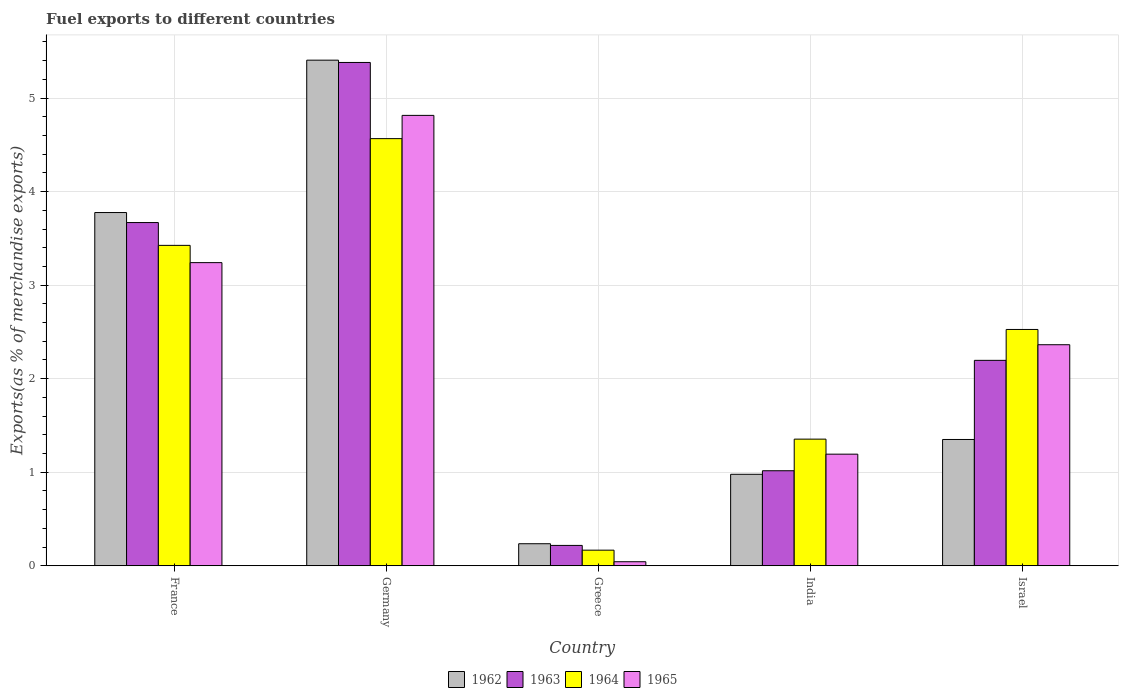Are the number of bars on each tick of the X-axis equal?
Offer a very short reply. Yes. How many bars are there on the 2nd tick from the left?
Ensure brevity in your answer.  4. How many bars are there on the 3rd tick from the right?
Offer a very short reply. 4. In how many cases, is the number of bars for a given country not equal to the number of legend labels?
Give a very brief answer. 0. What is the percentage of exports to different countries in 1962 in France?
Offer a terse response. 3.78. Across all countries, what is the maximum percentage of exports to different countries in 1962?
Ensure brevity in your answer.  5.4. Across all countries, what is the minimum percentage of exports to different countries in 1962?
Your answer should be compact. 0.24. What is the total percentage of exports to different countries in 1964 in the graph?
Provide a succinct answer. 12.04. What is the difference between the percentage of exports to different countries in 1963 in Germany and that in Greece?
Ensure brevity in your answer.  5.16. What is the difference between the percentage of exports to different countries in 1964 in Israel and the percentage of exports to different countries in 1963 in India?
Give a very brief answer. 1.51. What is the average percentage of exports to different countries in 1962 per country?
Your answer should be compact. 2.35. What is the difference between the percentage of exports to different countries of/in 1964 and percentage of exports to different countries of/in 1963 in France?
Give a very brief answer. -0.24. In how many countries, is the percentage of exports to different countries in 1963 greater than 0.4 %?
Your answer should be compact. 4. What is the ratio of the percentage of exports to different countries in 1963 in France to that in India?
Offer a very short reply. 3.61. Is the difference between the percentage of exports to different countries in 1964 in Germany and Israel greater than the difference between the percentage of exports to different countries in 1963 in Germany and Israel?
Your answer should be compact. No. What is the difference between the highest and the second highest percentage of exports to different countries in 1964?
Provide a short and direct response. -0.9. What is the difference between the highest and the lowest percentage of exports to different countries in 1965?
Make the answer very short. 4.77. In how many countries, is the percentage of exports to different countries in 1964 greater than the average percentage of exports to different countries in 1964 taken over all countries?
Provide a short and direct response. 3. What does the 4th bar from the left in India represents?
Provide a short and direct response. 1965. What does the 3rd bar from the right in Germany represents?
Ensure brevity in your answer.  1963. How many bars are there?
Provide a short and direct response. 20. What is the difference between two consecutive major ticks on the Y-axis?
Offer a very short reply. 1. Are the values on the major ticks of Y-axis written in scientific E-notation?
Ensure brevity in your answer.  No. How many legend labels are there?
Your response must be concise. 4. How are the legend labels stacked?
Make the answer very short. Horizontal. What is the title of the graph?
Make the answer very short. Fuel exports to different countries. What is the label or title of the X-axis?
Offer a terse response. Country. What is the label or title of the Y-axis?
Keep it short and to the point. Exports(as % of merchandise exports). What is the Exports(as % of merchandise exports) in 1962 in France?
Provide a succinct answer. 3.78. What is the Exports(as % of merchandise exports) of 1963 in France?
Offer a very short reply. 3.67. What is the Exports(as % of merchandise exports) in 1964 in France?
Your response must be concise. 3.43. What is the Exports(as % of merchandise exports) in 1965 in France?
Your answer should be compact. 3.24. What is the Exports(as % of merchandise exports) of 1962 in Germany?
Offer a very short reply. 5.4. What is the Exports(as % of merchandise exports) in 1963 in Germany?
Your response must be concise. 5.38. What is the Exports(as % of merchandise exports) of 1964 in Germany?
Provide a succinct answer. 4.57. What is the Exports(as % of merchandise exports) in 1965 in Germany?
Make the answer very short. 4.81. What is the Exports(as % of merchandise exports) of 1962 in Greece?
Your answer should be compact. 0.24. What is the Exports(as % of merchandise exports) in 1963 in Greece?
Offer a terse response. 0.22. What is the Exports(as % of merchandise exports) in 1964 in Greece?
Provide a succinct answer. 0.17. What is the Exports(as % of merchandise exports) in 1965 in Greece?
Provide a short and direct response. 0.04. What is the Exports(as % of merchandise exports) in 1962 in India?
Offer a terse response. 0.98. What is the Exports(as % of merchandise exports) of 1963 in India?
Give a very brief answer. 1.02. What is the Exports(as % of merchandise exports) in 1964 in India?
Give a very brief answer. 1.35. What is the Exports(as % of merchandise exports) in 1965 in India?
Keep it short and to the point. 1.19. What is the Exports(as % of merchandise exports) in 1962 in Israel?
Your response must be concise. 1.35. What is the Exports(as % of merchandise exports) in 1963 in Israel?
Keep it short and to the point. 2.2. What is the Exports(as % of merchandise exports) of 1964 in Israel?
Give a very brief answer. 2.53. What is the Exports(as % of merchandise exports) of 1965 in Israel?
Provide a short and direct response. 2.36. Across all countries, what is the maximum Exports(as % of merchandise exports) of 1962?
Ensure brevity in your answer.  5.4. Across all countries, what is the maximum Exports(as % of merchandise exports) in 1963?
Provide a short and direct response. 5.38. Across all countries, what is the maximum Exports(as % of merchandise exports) of 1964?
Give a very brief answer. 4.57. Across all countries, what is the maximum Exports(as % of merchandise exports) of 1965?
Ensure brevity in your answer.  4.81. Across all countries, what is the minimum Exports(as % of merchandise exports) in 1962?
Your answer should be compact. 0.24. Across all countries, what is the minimum Exports(as % of merchandise exports) of 1963?
Your response must be concise. 0.22. Across all countries, what is the minimum Exports(as % of merchandise exports) of 1964?
Your response must be concise. 0.17. Across all countries, what is the minimum Exports(as % of merchandise exports) of 1965?
Make the answer very short. 0.04. What is the total Exports(as % of merchandise exports) of 1962 in the graph?
Offer a terse response. 11.75. What is the total Exports(as % of merchandise exports) of 1963 in the graph?
Provide a succinct answer. 12.48. What is the total Exports(as % of merchandise exports) in 1964 in the graph?
Give a very brief answer. 12.04. What is the total Exports(as % of merchandise exports) of 1965 in the graph?
Provide a succinct answer. 11.66. What is the difference between the Exports(as % of merchandise exports) of 1962 in France and that in Germany?
Offer a terse response. -1.63. What is the difference between the Exports(as % of merchandise exports) in 1963 in France and that in Germany?
Offer a terse response. -1.71. What is the difference between the Exports(as % of merchandise exports) of 1964 in France and that in Germany?
Provide a short and direct response. -1.14. What is the difference between the Exports(as % of merchandise exports) of 1965 in France and that in Germany?
Your response must be concise. -1.57. What is the difference between the Exports(as % of merchandise exports) in 1962 in France and that in Greece?
Your answer should be compact. 3.54. What is the difference between the Exports(as % of merchandise exports) in 1963 in France and that in Greece?
Offer a terse response. 3.45. What is the difference between the Exports(as % of merchandise exports) in 1964 in France and that in Greece?
Provide a short and direct response. 3.26. What is the difference between the Exports(as % of merchandise exports) in 1965 in France and that in Greece?
Offer a very short reply. 3.2. What is the difference between the Exports(as % of merchandise exports) in 1962 in France and that in India?
Offer a very short reply. 2.8. What is the difference between the Exports(as % of merchandise exports) in 1963 in France and that in India?
Give a very brief answer. 2.65. What is the difference between the Exports(as % of merchandise exports) in 1964 in France and that in India?
Ensure brevity in your answer.  2.07. What is the difference between the Exports(as % of merchandise exports) in 1965 in France and that in India?
Make the answer very short. 2.05. What is the difference between the Exports(as % of merchandise exports) in 1962 in France and that in Israel?
Make the answer very short. 2.43. What is the difference between the Exports(as % of merchandise exports) of 1963 in France and that in Israel?
Your answer should be very brief. 1.47. What is the difference between the Exports(as % of merchandise exports) in 1964 in France and that in Israel?
Your answer should be compact. 0.9. What is the difference between the Exports(as % of merchandise exports) of 1965 in France and that in Israel?
Make the answer very short. 0.88. What is the difference between the Exports(as % of merchandise exports) in 1962 in Germany and that in Greece?
Your response must be concise. 5.17. What is the difference between the Exports(as % of merchandise exports) of 1963 in Germany and that in Greece?
Offer a very short reply. 5.16. What is the difference between the Exports(as % of merchandise exports) in 1964 in Germany and that in Greece?
Make the answer very short. 4.4. What is the difference between the Exports(as % of merchandise exports) in 1965 in Germany and that in Greece?
Offer a terse response. 4.77. What is the difference between the Exports(as % of merchandise exports) in 1962 in Germany and that in India?
Offer a very short reply. 4.43. What is the difference between the Exports(as % of merchandise exports) of 1963 in Germany and that in India?
Provide a short and direct response. 4.36. What is the difference between the Exports(as % of merchandise exports) in 1964 in Germany and that in India?
Give a very brief answer. 3.21. What is the difference between the Exports(as % of merchandise exports) in 1965 in Germany and that in India?
Keep it short and to the point. 3.62. What is the difference between the Exports(as % of merchandise exports) of 1962 in Germany and that in Israel?
Give a very brief answer. 4.05. What is the difference between the Exports(as % of merchandise exports) in 1963 in Germany and that in Israel?
Provide a short and direct response. 3.18. What is the difference between the Exports(as % of merchandise exports) of 1964 in Germany and that in Israel?
Offer a very short reply. 2.04. What is the difference between the Exports(as % of merchandise exports) in 1965 in Germany and that in Israel?
Make the answer very short. 2.45. What is the difference between the Exports(as % of merchandise exports) in 1962 in Greece and that in India?
Your answer should be compact. -0.74. What is the difference between the Exports(as % of merchandise exports) of 1963 in Greece and that in India?
Ensure brevity in your answer.  -0.8. What is the difference between the Exports(as % of merchandise exports) in 1964 in Greece and that in India?
Make the answer very short. -1.19. What is the difference between the Exports(as % of merchandise exports) of 1965 in Greece and that in India?
Provide a succinct answer. -1.15. What is the difference between the Exports(as % of merchandise exports) in 1962 in Greece and that in Israel?
Give a very brief answer. -1.11. What is the difference between the Exports(as % of merchandise exports) of 1963 in Greece and that in Israel?
Your answer should be compact. -1.98. What is the difference between the Exports(as % of merchandise exports) in 1964 in Greece and that in Israel?
Provide a succinct answer. -2.36. What is the difference between the Exports(as % of merchandise exports) of 1965 in Greece and that in Israel?
Keep it short and to the point. -2.32. What is the difference between the Exports(as % of merchandise exports) of 1962 in India and that in Israel?
Your answer should be very brief. -0.37. What is the difference between the Exports(as % of merchandise exports) of 1963 in India and that in Israel?
Offer a terse response. -1.18. What is the difference between the Exports(as % of merchandise exports) of 1964 in India and that in Israel?
Provide a succinct answer. -1.17. What is the difference between the Exports(as % of merchandise exports) in 1965 in India and that in Israel?
Your answer should be compact. -1.17. What is the difference between the Exports(as % of merchandise exports) of 1962 in France and the Exports(as % of merchandise exports) of 1963 in Germany?
Give a very brief answer. -1.6. What is the difference between the Exports(as % of merchandise exports) of 1962 in France and the Exports(as % of merchandise exports) of 1964 in Germany?
Give a very brief answer. -0.79. What is the difference between the Exports(as % of merchandise exports) in 1962 in France and the Exports(as % of merchandise exports) in 1965 in Germany?
Give a very brief answer. -1.04. What is the difference between the Exports(as % of merchandise exports) of 1963 in France and the Exports(as % of merchandise exports) of 1964 in Germany?
Your answer should be compact. -0.9. What is the difference between the Exports(as % of merchandise exports) of 1963 in France and the Exports(as % of merchandise exports) of 1965 in Germany?
Keep it short and to the point. -1.15. What is the difference between the Exports(as % of merchandise exports) of 1964 in France and the Exports(as % of merchandise exports) of 1965 in Germany?
Provide a succinct answer. -1.39. What is the difference between the Exports(as % of merchandise exports) of 1962 in France and the Exports(as % of merchandise exports) of 1963 in Greece?
Your answer should be compact. 3.56. What is the difference between the Exports(as % of merchandise exports) of 1962 in France and the Exports(as % of merchandise exports) of 1964 in Greece?
Your answer should be compact. 3.61. What is the difference between the Exports(as % of merchandise exports) in 1962 in France and the Exports(as % of merchandise exports) in 1965 in Greece?
Your answer should be compact. 3.73. What is the difference between the Exports(as % of merchandise exports) of 1963 in France and the Exports(as % of merchandise exports) of 1964 in Greece?
Make the answer very short. 3.5. What is the difference between the Exports(as % of merchandise exports) in 1963 in France and the Exports(as % of merchandise exports) in 1965 in Greece?
Provide a short and direct response. 3.63. What is the difference between the Exports(as % of merchandise exports) of 1964 in France and the Exports(as % of merchandise exports) of 1965 in Greece?
Your answer should be very brief. 3.38. What is the difference between the Exports(as % of merchandise exports) in 1962 in France and the Exports(as % of merchandise exports) in 1963 in India?
Provide a short and direct response. 2.76. What is the difference between the Exports(as % of merchandise exports) of 1962 in France and the Exports(as % of merchandise exports) of 1964 in India?
Provide a succinct answer. 2.42. What is the difference between the Exports(as % of merchandise exports) in 1962 in France and the Exports(as % of merchandise exports) in 1965 in India?
Your response must be concise. 2.58. What is the difference between the Exports(as % of merchandise exports) of 1963 in France and the Exports(as % of merchandise exports) of 1964 in India?
Your answer should be compact. 2.32. What is the difference between the Exports(as % of merchandise exports) in 1963 in France and the Exports(as % of merchandise exports) in 1965 in India?
Keep it short and to the point. 2.48. What is the difference between the Exports(as % of merchandise exports) of 1964 in France and the Exports(as % of merchandise exports) of 1965 in India?
Offer a terse response. 2.23. What is the difference between the Exports(as % of merchandise exports) of 1962 in France and the Exports(as % of merchandise exports) of 1963 in Israel?
Your answer should be compact. 1.58. What is the difference between the Exports(as % of merchandise exports) in 1962 in France and the Exports(as % of merchandise exports) in 1964 in Israel?
Provide a succinct answer. 1.25. What is the difference between the Exports(as % of merchandise exports) of 1962 in France and the Exports(as % of merchandise exports) of 1965 in Israel?
Ensure brevity in your answer.  1.41. What is the difference between the Exports(as % of merchandise exports) of 1963 in France and the Exports(as % of merchandise exports) of 1964 in Israel?
Ensure brevity in your answer.  1.14. What is the difference between the Exports(as % of merchandise exports) of 1963 in France and the Exports(as % of merchandise exports) of 1965 in Israel?
Offer a very short reply. 1.31. What is the difference between the Exports(as % of merchandise exports) in 1964 in France and the Exports(as % of merchandise exports) in 1965 in Israel?
Ensure brevity in your answer.  1.06. What is the difference between the Exports(as % of merchandise exports) in 1962 in Germany and the Exports(as % of merchandise exports) in 1963 in Greece?
Your response must be concise. 5.19. What is the difference between the Exports(as % of merchandise exports) of 1962 in Germany and the Exports(as % of merchandise exports) of 1964 in Greece?
Your answer should be very brief. 5.24. What is the difference between the Exports(as % of merchandise exports) of 1962 in Germany and the Exports(as % of merchandise exports) of 1965 in Greece?
Offer a terse response. 5.36. What is the difference between the Exports(as % of merchandise exports) of 1963 in Germany and the Exports(as % of merchandise exports) of 1964 in Greece?
Give a very brief answer. 5.21. What is the difference between the Exports(as % of merchandise exports) in 1963 in Germany and the Exports(as % of merchandise exports) in 1965 in Greece?
Your answer should be compact. 5.34. What is the difference between the Exports(as % of merchandise exports) in 1964 in Germany and the Exports(as % of merchandise exports) in 1965 in Greece?
Keep it short and to the point. 4.52. What is the difference between the Exports(as % of merchandise exports) of 1962 in Germany and the Exports(as % of merchandise exports) of 1963 in India?
Offer a terse response. 4.39. What is the difference between the Exports(as % of merchandise exports) in 1962 in Germany and the Exports(as % of merchandise exports) in 1964 in India?
Your answer should be very brief. 4.05. What is the difference between the Exports(as % of merchandise exports) of 1962 in Germany and the Exports(as % of merchandise exports) of 1965 in India?
Offer a very short reply. 4.21. What is the difference between the Exports(as % of merchandise exports) in 1963 in Germany and the Exports(as % of merchandise exports) in 1964 in India?
Keep it short and to the point. 4.03. What is the difference between the Exports(as % of merchandise exports) in 1963 in Germany and the Exports(as % of merchandise exports) in 1965 in India?
Ensure brevity in your answer.  4.19. What is the difference between the Exports(as % of merchandise exports) in 1964 in Germany and the Exports(as % of merchandise exports) in 1965 in India?
Ensure brevity in your answer.  3.37. What is the difference between the Exports(as % of merchandise exports) in 1962 in Germany and the Exports(as % of merchandise exports) in 1963 in Israel?
Your answer should be very brief. 3.21. What is the difference between the Exports(as % of merchandise exports) in 1962 in Germany and the Exports(as % of merchandise exports) in 1964 in Israel?
Offer a very short reply. 2.88. What is the difference between the Exports(as % of merchandise exports) of 1962 in Germany and the Exports(as % of merchandise exports) of 1965 in Israel?
Your answer should be compact. 3.04. What is the difference between the Exports(as % of merchandise exports) of 1963 in Germany and the Exports(as % of merchandise exports) of 1964 in Israel?
Provide a succinct answer. 2.85. What is the difference between the Exports(as % of merchandise exports) in 1963 in Germany and the Exports(as % of merchandise exports) in 1965 in Israel?
Offer a terse response. 3.02. What is the difference between the Exports(as % of merchandise exports) in 1964 in Germany and the Exports(as % of merchandise exports) in 1965 in Israel?
Your answer should be compact. 2.2. What is the difference between the Exports(as % of merchandise exports) of 1962 in Greece and the Exports(as % of merchandise exports) of 1963 in India?
Ensure brevity in your answer.  -0.78. What is the difference between the Exports(as % of merchandise exports) in 1962 in Greece and the Exports(as % of merchandise exports) in 1964 in India?
Offer a terse response. -1.12. What is the difference between the Exports(as % of merchandise exports) of 1962 in Greece and the Exports(as % of merchandise exports) of 1965 in India?
Provide a short and direct response. -0.96. What is the difference between the Exports(as % of merchandise exports) in 1963 in Greece and the Exports(as % of merchandise exports) in 1964 in India?
Provide a short and direct response. -1.14. What is the difference between the Exports(as % of merchandise exports) of 1963 in Greece and the Exports(as % of merchandise exports) of 1965 in India?
Provide a succinct answer. -0.98. What is the difference between the Exports(as % of merchandise exports) in 1964 in Greece and the Exports(as % of merchandise exports) in 1965 in India?
Make the answer very short. -1.03. What is the difference between the Exports(as % of merchandise exports) in 1962 in Greece and the Exports(as % of merchandise exports) in 1963 in Israel?
Provide a short and direct response. -1.96. What is the difference between the Exports(as % of merchandise exports) of 1962 in Greece and the Exports(as % of merchandise exports) of 1964 in Israel?
Keep it short and to the point. -2.29. What is the difference between the Exports(as % of merchandise exports) of 1962 in Greece and the Exports(as % of merchandise exports) of 1965 in Israel?
Provide a succinct answer. -2.13. What is the difference between the Exports(as % of merchandise exports) of 1963 in Greece and the Exports(as % of merchandise exports) of 1964 in Israel?
Your response must be concise. -2.31. What is the difference between the Exports(as % of merchandise exports) in 1963 in Greece and the Exports(as % of merchandise exports) in 1965 in Israel?
Provide a succinct answer. -2.15. What is the difference between the Exports(as % of merchandise exports) of 1964 in Greece and the Exports(as % of merchandise exports) of 1965 in Israel?
Provide a succinct answer. -2.2. What is the difference between the Exports(as % of merchandise exports) in 1962 in India and the Exports(as % of merchandise exports) in 1963 in Israel?
Provide a short and direct response. -1.22. What is the difference between the Exports(as % of merchandise exports) in 1962 in India and the Exports(as % of merchandise exports) in 1964 in Israel?
Make the answer very short. -1.55. What is the difference between the Exports(as % of merchandise exports) in 1962 in India and the Exports(as % of merchandise exports) in 1965 in Israel?
Provide a succinct answer. -1.38. What is the difference between the Exports(as % of merchandise exports) in 1963 in India and the Exports(as % of merchandise exports) in 1964 in Israel?
Offer a terse response. -1.51. What is the difference between the Exports(as % of merchandise exports) in 1963 in India and the Exports(as % of merchandise exports) in 1965 in Israel?
Keep it short and to the point. -1.35. What is the difference between the Exports(as % of merchandise exports) in 1964 in India and the Exports(as % of merchandise exports) in 1965 in Israel?
Your answer should be compact. -1.01. What is the average Exports(as % of merchandise exports) in 1962 per country?
Offer a very short reply. 2.35. What is the average Exports(as % of merchandise exports) of 1963 per country?
Your answer should be compact. 2.5. What is the average Exports(as % of merchandise exports) of 1964 per country?
Offer a very short reply. 2.41. What is the average Exports(as % of merchandise exports) in 1965 per country?
Provide a short and direct response. 2.33. What is the difference between the Exports(as % of merchandise exports) of 1962 and Exports(as % of merchandise exports) of 1963 in France?
Your answer should be very brief. 0.11. What is the difference between the Exports(as % of merchandise exports) in 1962 and Exports(as % of merchandise exports) in 1964 in France?
Your response must be concise. 0.35. What is the difference between the Exports(as % of merchandise exports) in 1962 and Exports(as % of merchandise exports) in 1965 in France?
Give a very brief answer. 0.54. What is the difference between the Exports(as % of merchandise exports) of 1963 and Exports(as % of merchandise exports) of 1964 in France?
Offer a very short reply. 0.24. What is the difference between the Exports(as % of merchandise exports) of 1963 and Exports(as % of merchandise exports) of 1965 in France?
Provide a short and direct response. 0.43. What is the difference between the Exports(as % of merchandise exports) of 1964 and Exports(as % of merchandise exports) of 1965 in France?
Your response must be concise. 0.18. What is the difference between the Exports(as % of merchandise exports) of 1962 and Exports(as % of merchandise exports) of 1963 in Germany?
Ensure brevity in your answer.  0.02. What is the difference between the Exports(as % of merchandise exports) of 1962 and Exports(as % of merchandise exports) of 1964 in Germany?
Your answer should be very brief. 0.84. What is the difference between the Exports(as % of merchandise exports) in 1962 and Exports(as % of merchandise exports) in 1965 in Germany?
Provide a succinct answer. 0.59. What is the difference between the Exports(as % of merchandise exports) in 1963 and Exports(as % of merchandise exports) in 1964 in Germany?
Keep it short and to the point. 0.81. What is the difference between the Exports(as % of merchandise exports) in 1963 and Exports(as % of merchandise exports) in 1965 in Germany?
Provide a short and direct response. 0.57. What is the difference between the Exports(as % of merchandise exports) in 1964 and Exports(as % of merchandise exports) in 1965 in Germany?
Offer a terse response. -0.25. What is the difference between the Exports(as % of merchandise exports) of 1962 and Exports(as % of merchandise exports) of 1963 in Greece?
Give a very brief answer. 0.02. What is the difference between the Exports(as % of merchandise exports) of 1962 and Exports(as % of merchandise exports) of 1964 in Greece?
Make the answer very short. 0.07. What is the difference between the Exports(as % of merchandise exports) in 1962 and Exports(as % of merchandise exports) in 1965 in Greece?
Your answer should be very brief. 0.19. What is the difference between the Exports(as % of merchandise exports) in 1963 and Exports(as % of merchandise exports) in 1964 in Greece?
Your answer should be compact. 0.05. What is the difference between the Exports(as % of merchandise exports) of 1963 and Exports(as % of merchandise exports) of 1965 in Greece?
Offer a terse response. 0.17. What is the difference between the Exports(as % of merchandise exports) in 1964 and Exports(as % of merchandise exports) in 1965 in Greece?
Offer a terse response. 0.12. What is the difference between the Exports(as % of merchandise exports) in 1962 and Exports(as % of merchandise exports) in 1963 in India?
Offer a very short reply. -0.04. What is the difference between the Exports(as % of merchandise exports) of 1962 and Exports(as % of merchandise exports) of 1964 in India?
Keep it short and to the point. -0.38. What is the difference between the Exports(as % of merchandise exports) of 1962 and Exports(as % of merchandise exports) of 1965 in India?
Ensure brevity in your answer.  -0.22. What is the difference between the Exports(as % of merchandise exports) of 1963 and Exports(as % of merchandise exports) of 1964 in India?
Provide a short and direct response. -0.34. What is the difference between the Exports(as % of merchandise exports) of 1963 and Exports(as % of merchandise exports) of 1965 in India?
Offer a very short reply. -0.18. What is the difference between the Exports(as % of merchandise exports) in 1964 and Exports(as % of merchandise exports) in 1965 in India?
Offer a very short reply. 0.16. What is the difference between the Exports(as % of merchandise exports) in 1962 and Exports(as % of merchandise exports) in 1963 in Israel?
Your answer should be very brief. -0.85. What is the difference between the Exports(as % of merchandise exports) of 1962 and Exports(as % of merchandise exports) of 1964 in Israel?
Your answer should be very brief. -1.18. What is the difference between the Exports(as % of merchandise exports) of 1962 and Exports(as % of merchandise exports) of 1965 in Israel?
Your response must be concise. -1.01. What is the difference between the Exports(as % of merchandise exports) in 1963 and Exports(as % of merchandise exports) in 1964 in Israel?
Make the answer very short. -0.33. What is the difference between the Exports(as % of merchandise exports) in 1963 and Exports(as % of merchandise exports) in 1965 in Israel?
Your answer should be very brief. -0.17. What is the difference between the Exports(as % of merchandise exports) of 1964 and Exports(as % of merchandise exports) of 1965 in Israel?
Provide a short and direct response. 0.16. What is the ratio of the Exports(as % of merchandise exports) of 1962 in France to that in Germany?
Provide a short and direct response. 0.7. What is the ratio of the Exports(as % of merchandise exports) in 1963 in France to that in Germany?
Provide a short and direct response. 0.68. What is the ratio of the Exports(as % of merchandise exports) of 1964 in France to that in Germany?
Make the answer very short. 0.75. What is the ratio of the Exports(as % of merchandise exports) of 1965 in France to that in Germany?
Provide a short and direct response. 0.67. What is the ratio of the Exports(as % of merchandise exports) of 1962 in France to that in Greece?
Make the answer very short. 16.01. What is the ratio of the Exports(as % of merchandise exports) in 1963 in France to that in Greece?
Keep it short and to the point. 16.85. What is the ratio of the Exports(as % of merchandise exports) in 1964 in France to that in Greece?
Your answer should be compact. 20.5. What is the ratio of the Exports(as % of merchandise exports) of 1965 in France to that in Greece?
Ensure brevity in your answer.  74.69. What is the ratio of the Exports(as % of merchandise exports) of 1962 in France to that in India?
Keep it short and to the point. 3.86. What is the ratio of the Exports(as % of merchandise exports) in 1963 in France to that in India?
Provide a short and direct response. 3.61. What is the ratio of the Exports(as % of merchandise exports) in 1964 in France to that in India?
Give a very brief answer. 2.53. What is the ratio of the Exports(as % of merchandise exports) of 1965 in France to that in India?
Make the answer very short. 2.72. What is the ratio of the Exports(as % of merchandise exports) of 1962 in France to that in Israel?
Your answer should be compact. 2.8. What is the ratio of the Exports(as % of merchandise exports) of 1963 in France to that in Israel?
Your response must be concise. 1.67. What is the ratio of the Exports(as % of merchandise exports) of 1964 in France to that in Israel?
Offer a terse response. 1.36. What is the ratio of the Exports(as % of merchandise exports) in 1965 in France to that in Israel?
Offer a terse response. 1.37. What is the ratio of the Exports(as % of merchandise exports) of 1962 in Germany to that in Greece?
Your answer should be compact. 22.91. What is the ratio of the Exports(as % of merchandise exports) of 1963 in Germany to that in Greece?
Your answer should be compact. 24.71. What is the ratio of the Exports(as % of merchandise exports) of 1964 in Germany to that in Greece?
Give a very brief answer. 27.34. What is the ratio of the Exports(as % of merchandise exports) in 1965 in Germany to that in Greece?
Ensure brevity in your answer.  110.96. What is the ratio of the Exports(as % of merchandise exports) in 1962 in Germany to that in India?
Provide a succinct answer. 5.53. What is the ratio of the Exports(as % of merchandise exports) in 1963 in Germany to that in India?
Offer a very short reply. 5.3. What is the ratio of the Exports(as % of merchandise exports) of 1964 in Germany to that in India?
Keep it short and to the point. 3.37. What is the ratio of the Exports(as % of merchandise exports) of 1965 in Germany to that in India?
Your response must be concise. 4.03. What is the ratio of the Exports(as % of merchandise exports) of 1962 in Germany to that in Israel?
Provide a succinct answer. 4. What is the ratio of the Exports(as % of merchandise exports) of 1963 in Germany to that in Israel?
Your response must be concise. 2.45. What is the ratio of the Exports(as % of merchandise exports) of 1964 in Germany to that in Israel?
Keep it short and to the point. 1.81. What is the ratio of the Exports(as % of merchandise exports) in 1965 in Germany to that in Israel?
Ensure brevity in your answer.  2.04. What is the ratio of the Exports(as % of merchandise exports) of 1962 in Greece to that in India?
Keep it short and to the point. 0.24. What is the ratio of the Exports(as % of merchandise exports) of 1963 in Greece to that in India?
Your response must be concise. 0.21. What is the ratio of the Exports(as % of merchandise exports) in 1964 in Greece to that in India?
Keep it short and to the point. 0.12. What is the ratio of the Exports(as % of merchandise exports) of 1965 in Greece to that in India?
Your answer should be very brief. 0.04. What is the ratio of the Exports(as % of merchandise exports) in 1962 in Greece to that in Israel?
Your response must be concise. 0.17. What is the ratio of the Exports(as % of merchandise exports) in 1963 in Greece to that in Israel?
Offer a terse response. 0.1. What is the ratio of the Exports(as % of merchandise exports) of 1964 in Greece to that in Israel?
Your answer should be compact. 0.07. What is the ratio of the Exports(as % of merchandise exports) of 1965 in Greece to that in Israel?
Provide a short and direct response. 0.02. What is the ratio of the Exports(as % of merchandise exports) in 1962 in India to that in Israel?
Provide a succinct answer. 0.72. What is the ratio of the Exports(as % of merchandise exports) in 1963 in India to that in Israel?
Your response must be concise. 0.46. What is the ratio of the Exports(as % of merchandise exports) in 1964 in India to that in Israel?
Provide a short and direct response. 0.54. What is the ratio of the Exports(as % of merchandise exports) in 1965 in India to that in Israel?
Offer a very short reply. 0.51. What is the difference between the highest and the second highest Exports(as % of merchandise exports) of 1962?
Offer a terse response. 1.63. What is the difference between the highest and the second highest Exports(as % of merchandise exports) of 1963?
Offer a very short reply. 1.71. What is the difference between the highest and the second highest Exports(as % of merchandise exports) of 1964?
Offer a terse response. 1.14. What is the difference between the highest and the second highest Exports(as % of merchandise exports) of 1965?
Your answer should be compact. 1.57. What is the difference between the highest and the lowest Exports(as % of merchandise exports) in 1962?
Your response must be concise. 5.17. What is the difference between the highest and the lowest Exports(as % of merchandise exports) of 1963?
Keep it short and to the point. 5.16. What is the difference between the highest and the lowest Exports(as % of merchandise exports) of 1964?
Your answer should be compact. 4.4. What is the difference between the highest and the lowest Exports(as % of merchandise exports) of 1965?
Make the answer very short. 4.77. 